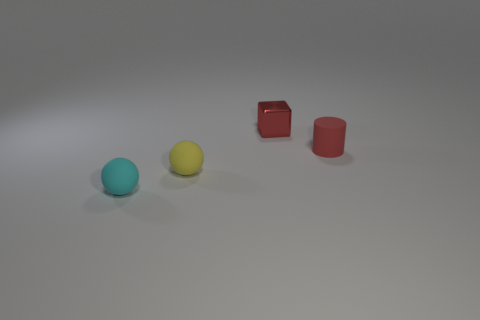Add 2 shiny things. How many objects exist? 6 Subtract all cylinders. How many objects are left? 3 Add 2 tiny gray shiny cylinders. How many tiny gray shiny cylinders exist? 2 Subtract 0 brown cubes. How many objects are left? 4 Subtract all tiny purple metal objects. Subtract all small objects. How many objects are left? 0 Add 2 small cyan things. How many small cyan things are left? 3 